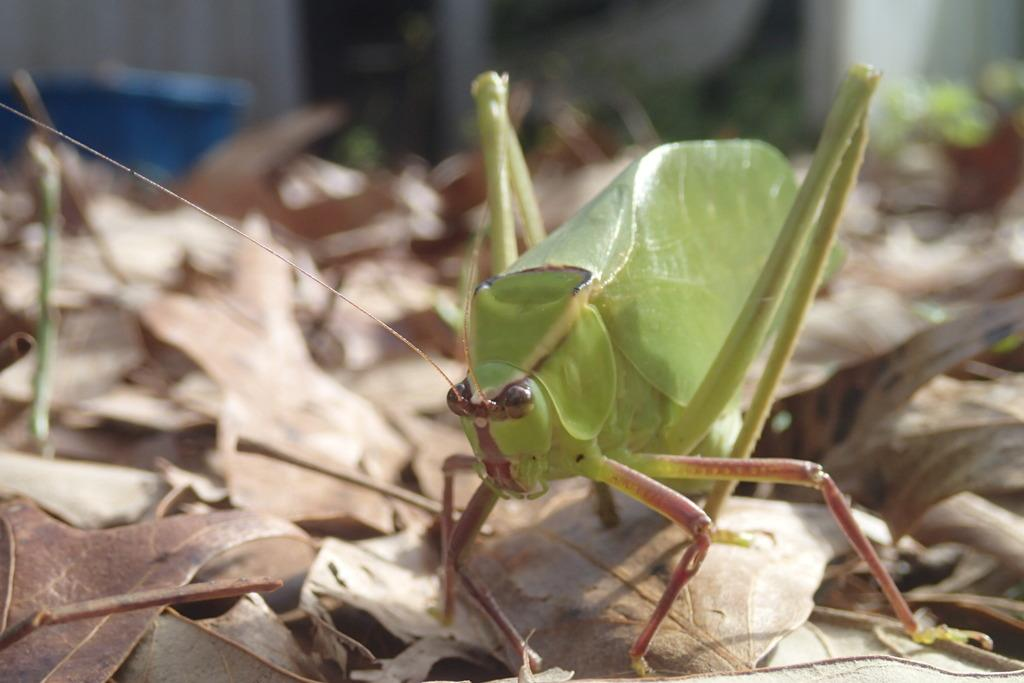What is on the dried leaves in the image? There is an insect on the dried leaves. What can be seen near the dried leaves in the image? There is a dustbin and a wall in the image. What type of vegetation is present in the image? There are dry leaves and small plants in the image. What is on the surface in the image? There are objects on the surface in the image. What language is the insect reading on the dried leaves in the image? There is no indication that the insect is reading anything in the image, and insects do not read languages. 